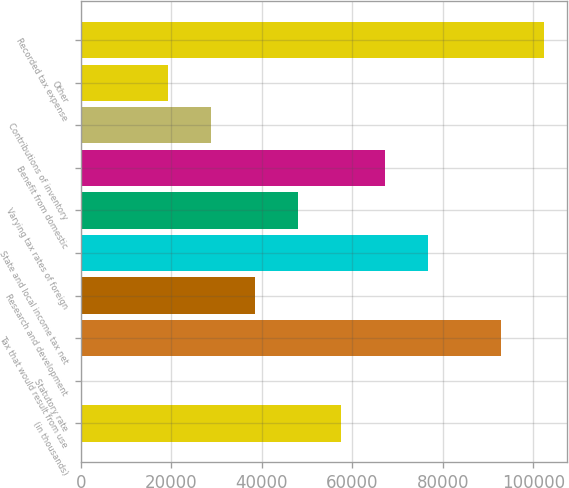<chart> <loc_0><loc_0><loc_500><loc_500><bar_chart><fcel>(in thousands)<fcel>Statutory rate<fcel>Tax that would result from use<fcel>Research and development<fcel>State and local income tax net<fcel>Varying tax rates of foreign<fcel>Benefit from domestic<fcel>Contributions of inventory<fcel>Other<fcel>Recorded tax expense<nl><fcel>57554<fcel>35<fcel>92726<fcel>38381<fcel>76727<fcel>47967.5<fcel>67140.5<fcel>28794.5<fcel>19208<fcel>102312<nl></chart> 